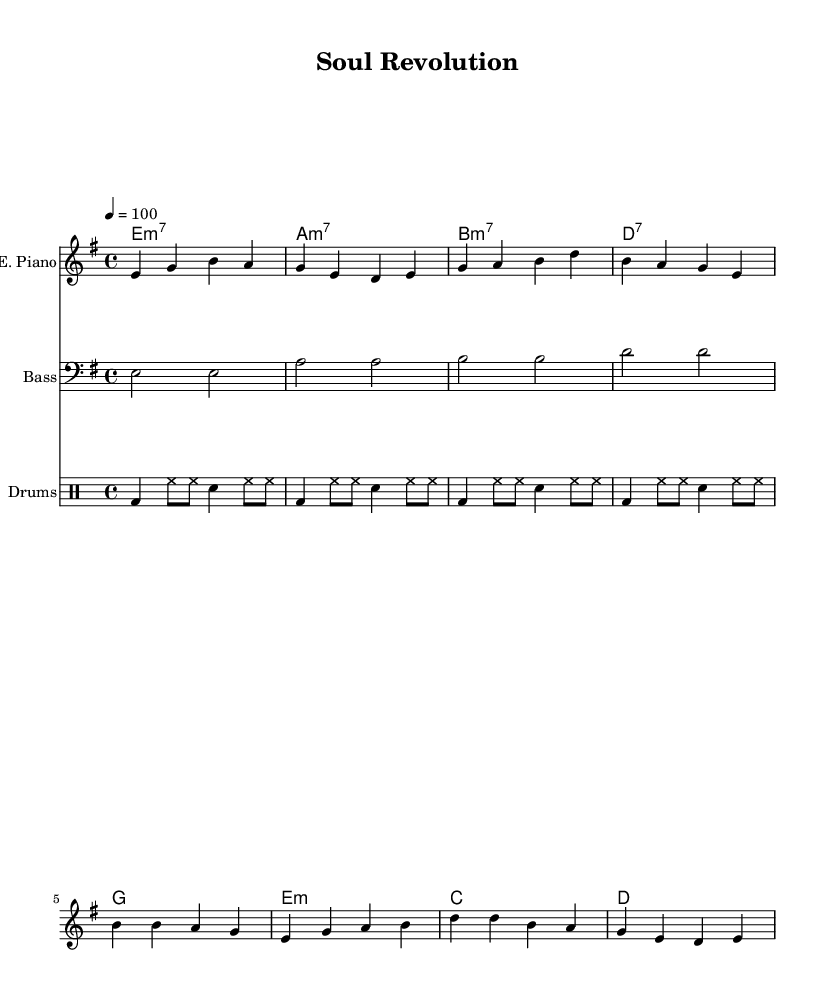What is the key signature of this music? The key signature is E minor, indicated by one sharp (F#) on the staff. The key signature is found at the beginning of the staff, directly after the clef symbol.
Answer: E minor What is the time signature of this music? The time signature is 4/4, which is indicated by the two numbers at the beginning of the score. The top number (4) indicates four beats per measure, and the bottom number (4) indicates that a quarter note receives one beat.
Answer: 4/4 What is the tempo marking for this music? The tempo marking shows a quarter note equals 100, which indicates the speed at which the piece should be played. This is written as "4 = 100" in the tempo instruction.
Answer: 100 How many measures are in the drum pattern? The drum pattern consists of four measures, as indicated by the division of the rhythm and the groups of beats laid out in the drummode section. Each measure is separated by a bar line.
Answer: 4 What chord is played on the first measure? The chord in the first measure is E minor 7, which is represented by the "e1:m7" notation in the chord section. This indicates the composing notes and their quality.
Answer: E minor 7 Which instrument plays the melody? The electric piano plays the melody, as indicated by its presence at the top of the score and the notes laid out for it beneath the instrument's name.
Answer: Electric Piano What is the bass note in the third measure? The bass note in the third measure is B, which is shown in the bass guitar staff. Each note indicates the pitch being played in that measure.
Answer: B 